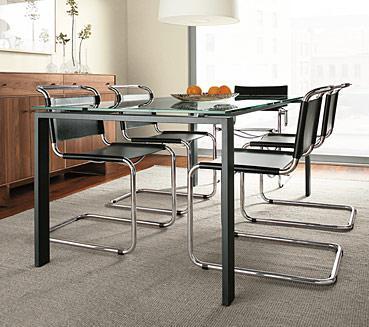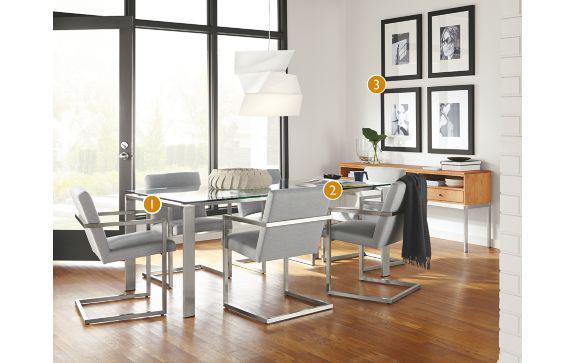The first image is the image on the left, the second image is the image on the right. For the images displayed, is the sentence "There is a white hanging lamp over the table in at least one of the images." factually correct? Answer yes or no. Yes. The first image is the image on the left, the second image is the image on the right. Assess this claim about the two images: "A dining set features a dark table top and four-legged chairs with solid, monochrome backs and seats.". Correct or not? Answer yes or no. No. 